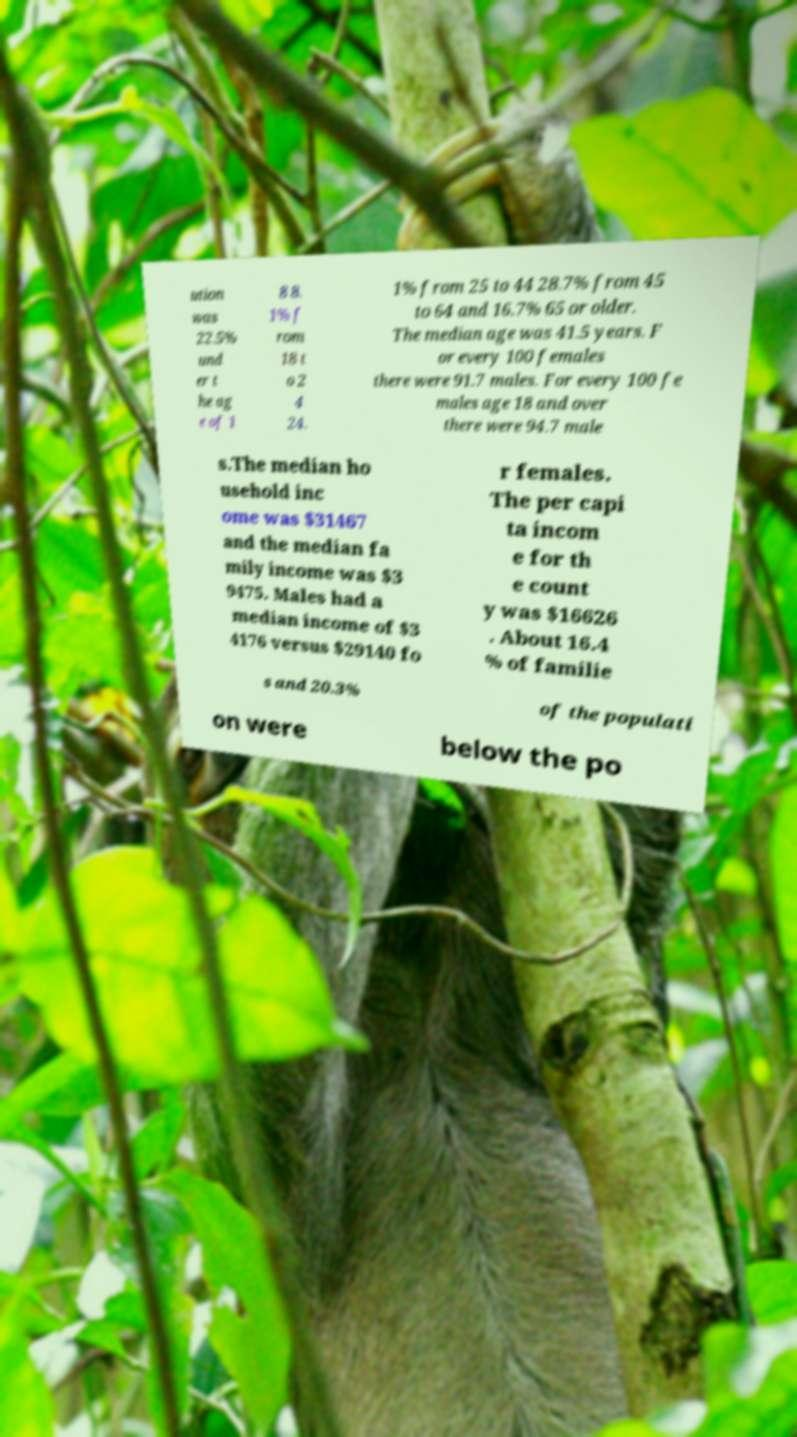I need the written content from this picture converted into text. Can you do that? ution was 22.5% und er t he ag e of 1 8 8. 1% f rom 18 t o 2 4 24. 1% from 25 to 44 28.7% from 45 to 64 and 16.7% 65 or older. The median age was 41.5 years. F or every 100 females there were 91.7 males. For every 100 fe males age 18 and over there were 94.7 male s.The median ho usehold inc ome was $31467 and the median fa mily income was $3 9475. Males had a median income of $3 4176 versus $29140 fo r females. The per capi ta incom e for th e count y was $16626 . About 16.4 % of familie s and 20.3% of the populati on were below the po 